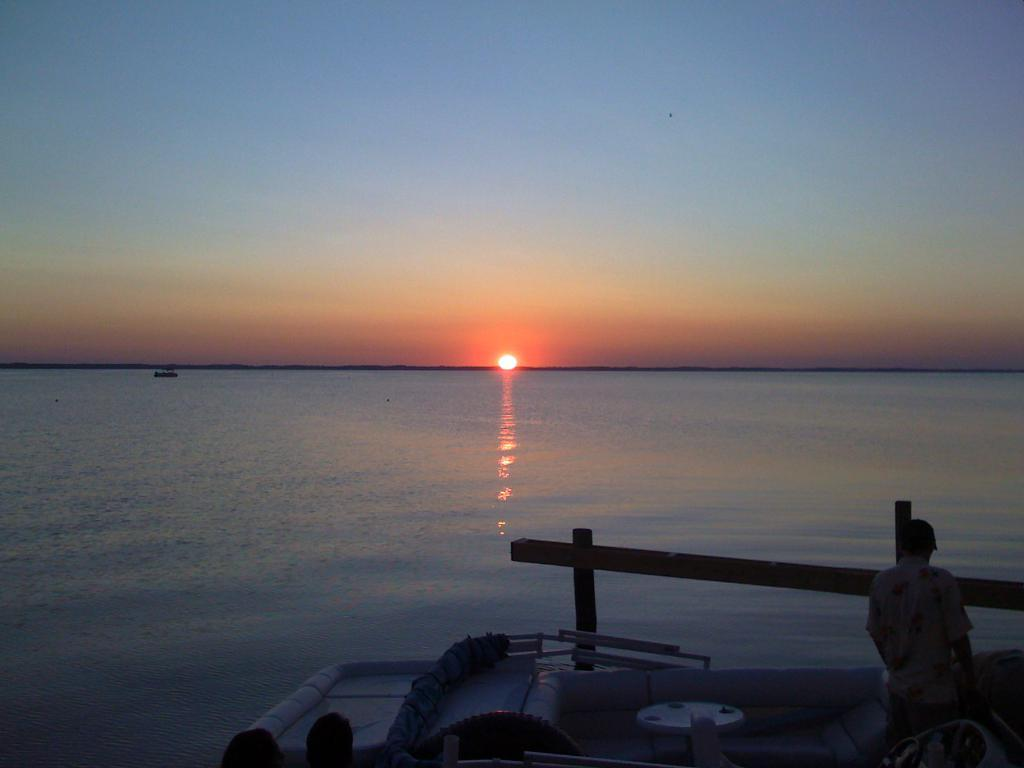What natural feature is present in the image? The image contains the sea. Can you describe the person in the image? There is a person standing in the image. What is located at the bottom of the image? Human heads and objects are visible at the bottom of the image, along with poles. What is visible at the top of the image? The sky is visible at the top of the image. What type of mint is being used to brush the person's teeth in the image? There is no mint or toothbrush present in the image. What trick is the person performing in the image? There is no trick being performed in the image; the person is simply standing. 